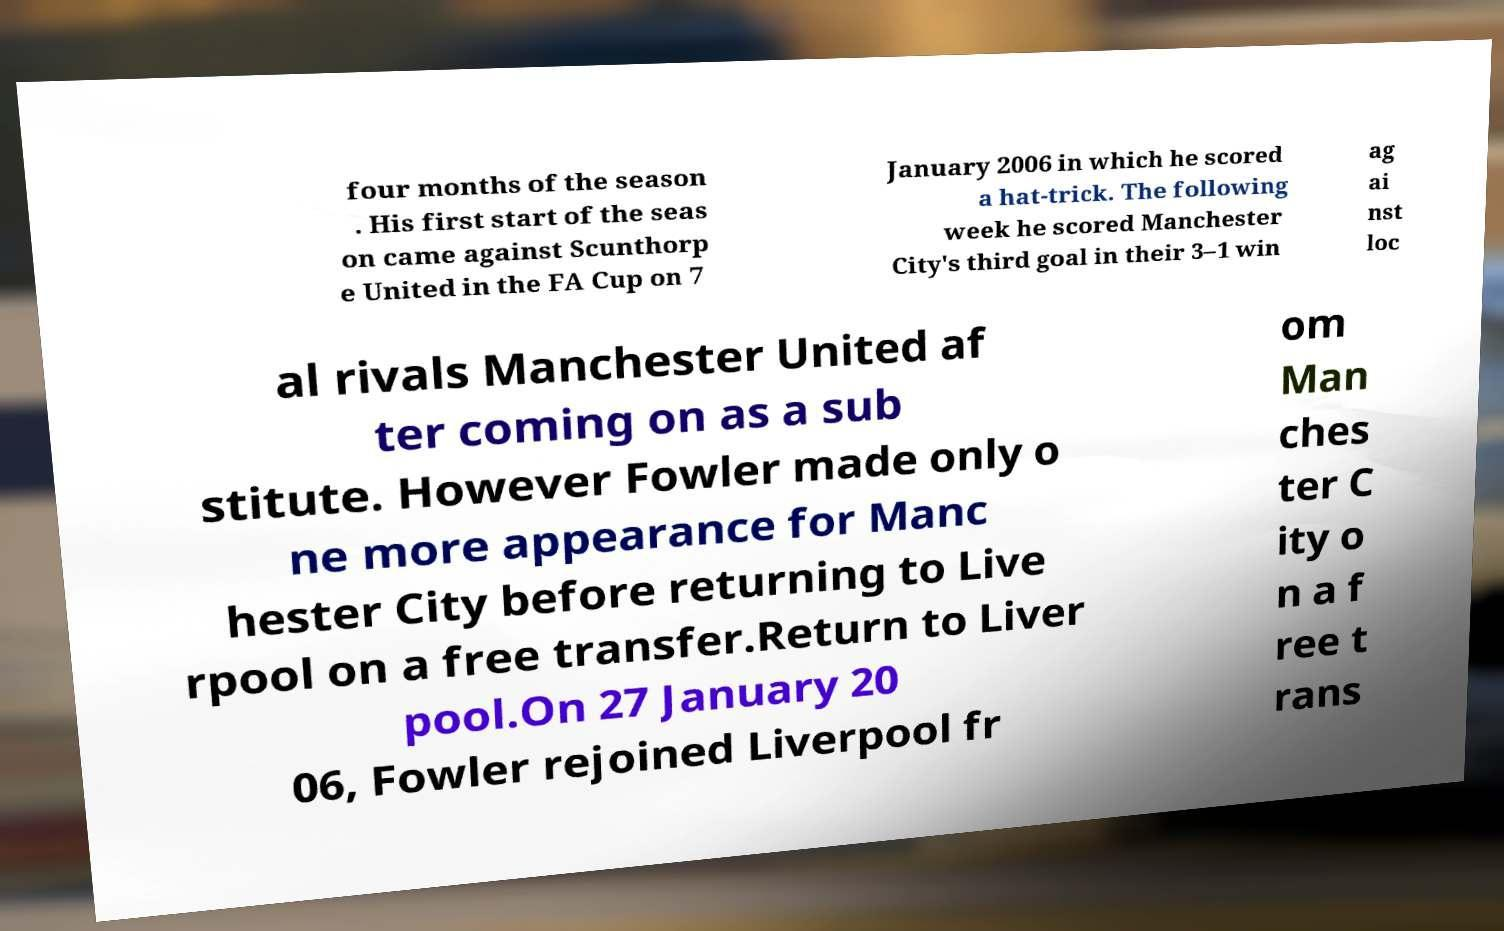Please read and relay the text visible in this image. What does it say? four months of the season . His first start of the seas on came against Scunthorp e United in the FA Cup on 7 January 2006 in which he scored a hat-trick. The following week he scored Manchester City's third goal in their 3–1 win ag ai nst loc al rivals Manchester United af ter coming on as a sub stitute. However Fowler made only o ne more appearance for Manc hester City before returning to Live rpool on a free transfer.Return to Liver pool.On 27 January 20 06, Fowler rejoined Liverpool fr om Man ches ter C ity o n a f ree t rans 